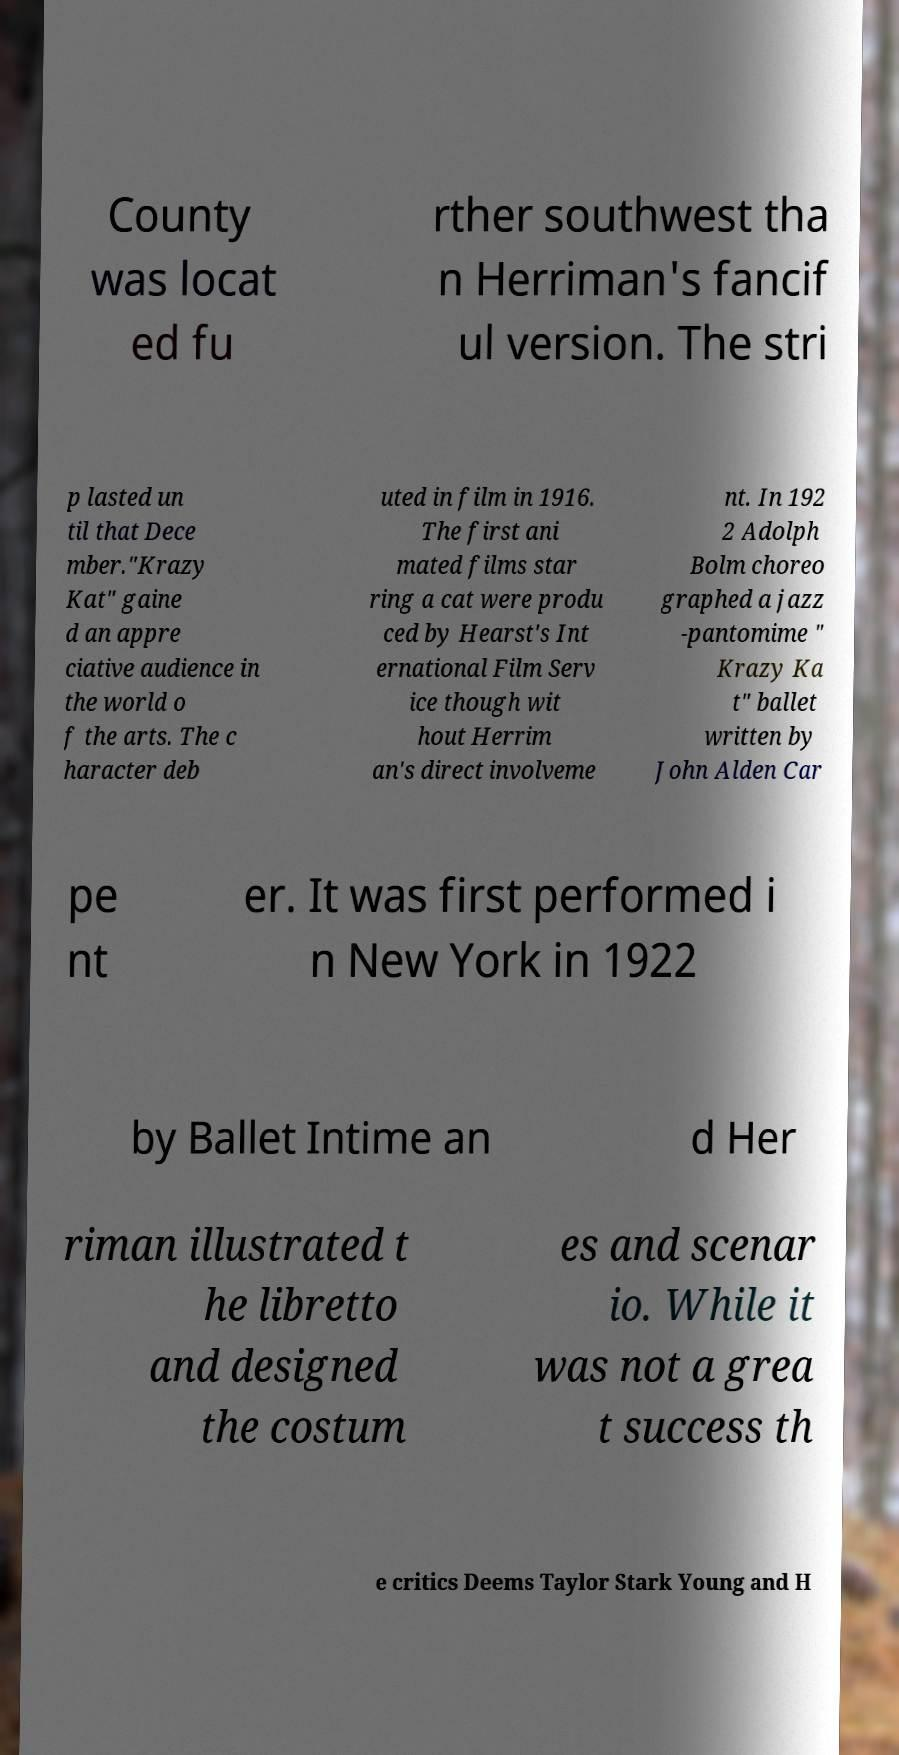What messages or text are displayed in this image? I need them in a readable, typed format. County was locat ed fu rther southwest tha n Herriman's fancif ul version. The stri p lasted un til that Dece mber."Krazy Kat" gaine d an appre ciative audience in the world o f the arts. The c haracter deb uted in film in 1916. The first ani mated films star ring a cat were produ ced by Hearst's Int ernational Film Serv ice though wit hout Herrim an's direct involveme nt. In 192 2 Adolph Bolm choreo graphed a jazz -pantomime " Krazy Ka t" ballet written by John Alden Car pe nt er. It was first performed i n New York in 1922 by Ballet Intime an d Her riman illustrated t he libretto and designed the costum es and scenar io. While it was not a grea t success th e critics Deems Taylor Stark Young and H 